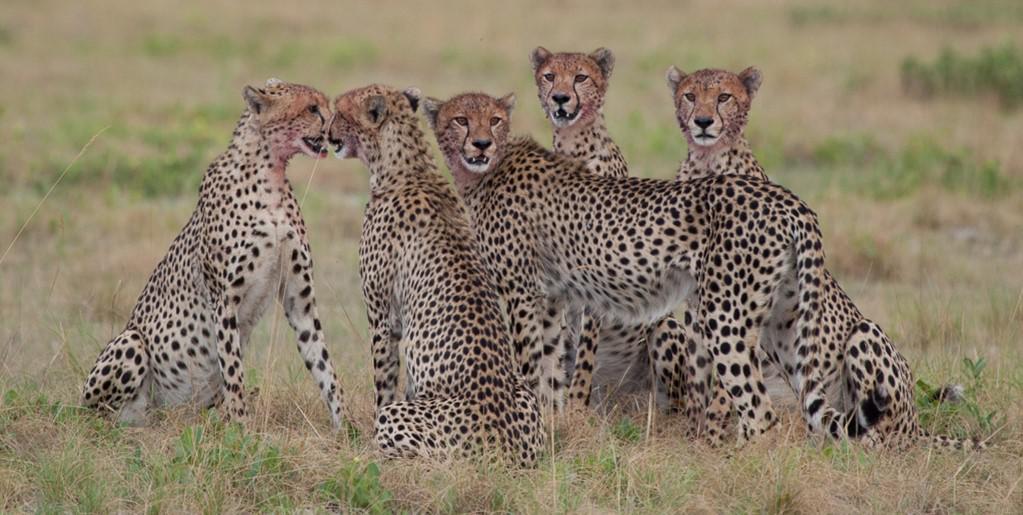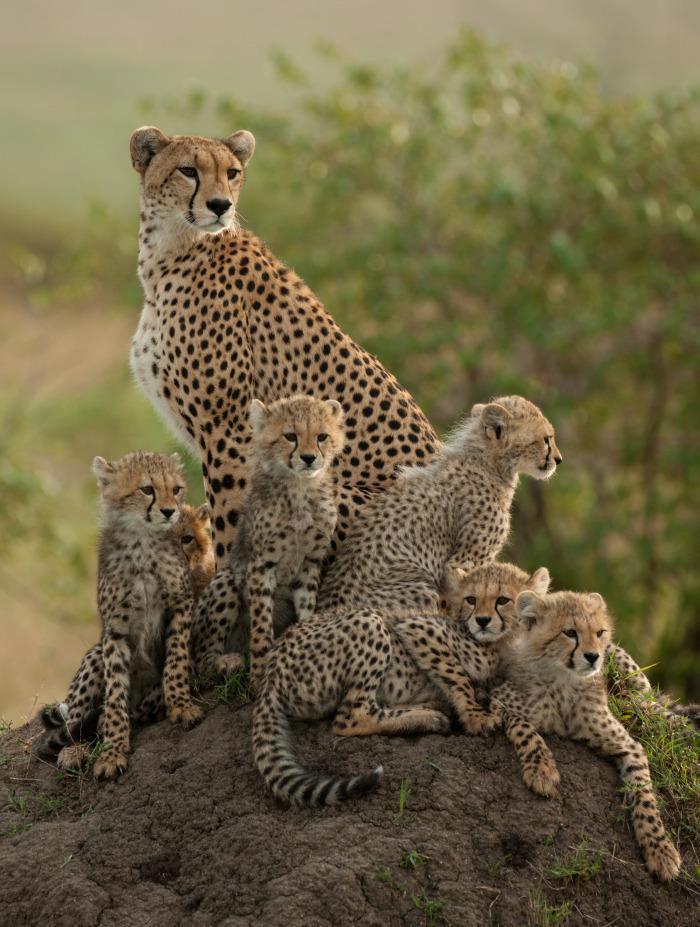The first image is the image on the left, the second image is the image on the right. Examine the images to the left and right. Is the description "The cheetahs are shown with their prey in at least one of the images." accurate? Answer yes or no. No. The first image is the image on the left, the second image is the image on the right. For the images shown, is this caption "Each image shows a close group of wild cats, and no image shows a prey animal." true? Answer yes or no. Yes. 